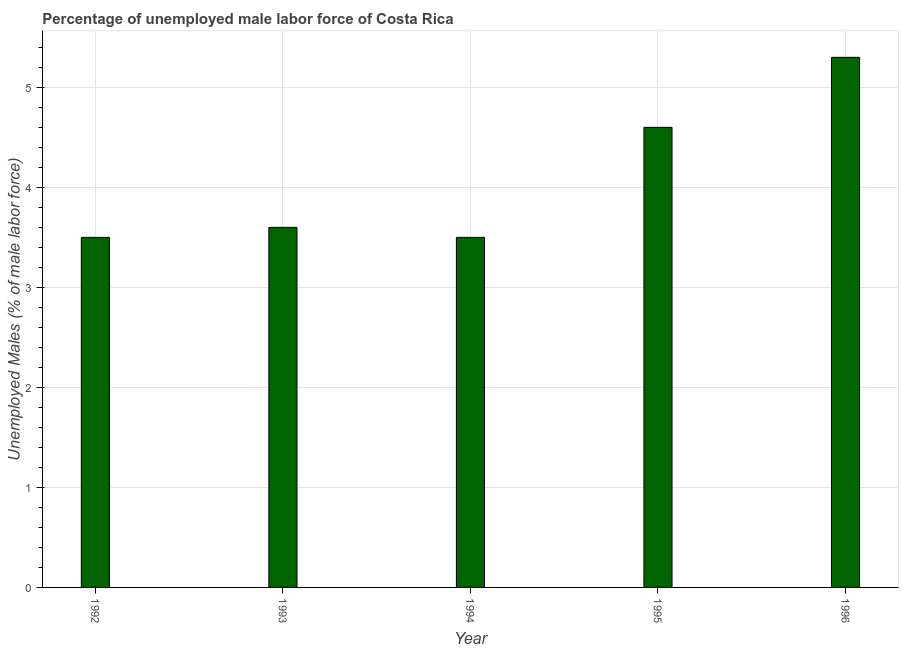Does the graph contain grids?
Ensure brevity in your answer.  Yes. What is the title of the graph?
Your answer should be compact. Percentage of unemployed male labor force of Costa Rica. What is the label or title of the X-axis?
Ensure brevity in your answer.  Year. What is the label or title of the Y-axis?
Make the answer very short. Unemployed Males (% of male labor force). What is the total unemployed male labour force in 1996?
Provide a succinct answer. 5.3. Across all years, what is the maximum total unemployed male labour force?
Make the answer very short. 5.3. Across all years, what is the minimum total unemployed male labour force?
Your answer should be compact. 3.5. In which year was the total unemployed male labour force maximum?
Your response must be concise. 1996. In which year was the total unemployed male labour force minimum?
Offer a terse response. 1992. What is the sum of the total unemployed male labour force?
Provide a succinct answer. 20.5. What is the median total unemployed male labour force?
Give a very brief answer. 3.6. In how many years, is the total unemployed male labour force greater than 0.6 %?
Offer a very short reply. 5. Do a majority of the years between 1992 and 1996 (inclusive) have total unemployed male labour force greater than 3.2 %?
Make the answer very short. Yes. Is the difference between the total unemployed male labour force in 1994 and 1995 greater than the difference between any two years?
Offer a very short reply. No. Is the sum of the total unemployed male labour force in 1992 and 1995 greater than the maximum total unemployed male labour force across all years?
Your answer should be compact. Yes. What is the difference between the highest and the lowest total unemployed male labour force?
Offer a terse response. 1.8. How many bars are there?
Your answer should be compact. 5. What is the Unemployed Males (% of male labor force) in 1993?
Provide a succinct answer. 3.6. What is the Unemployed Males (% of male labor force) in 1994?
Your answer should be compact. 3.5. What is the Unemployed Males (% of male labor force) of 1995?
Your answer should be compact. 4.6. What is the Unemployed Males (% of male labor force) of 1996?
Your answer should be compact. 5.3. What is the difference between the Unemployed Males (% of male labor force) in 1992 and 1995?
Offer a very short reply. -1.1. What is the ratio of the Unemployed Males (% of male labor force) in 1992 to that in 1993?
Provide a short and direct response. 0.97. What is the ratio of the Unemployed Males (% of male labor force) in 1992 to that in 1994?
Ensure brevity in your answer.  1. What is the ratio of the Unemployed Males (% of male labor force) in 1992 to that in 1995?
Offer a terse response. 0.76. What is the ratio of the Unemployed Males (% of male labor force) in 1992 to that in 1996?
Offer a very short reply. 0.66. What is the ratio of the Unemployed Males (% of male labor force) in 1993 to that in 1994?
Provide a succinct answer. 1.03. What is the ratio of the Unemployed Males (% of male labor force) in 1993 to that in 1995?
Your response must be concise. 0.78. What is the ratio of the Unemployed Males (% of male labor force) in 1993 to that in 1996?
Make the answer very short. 0.68. What is the ratio of the Unemployed Males (% of male labor force) in 1994 to that in 1995?
Provide a short and direct response. 0.76. What is the ratio of the Unemployed Males (% of male labor force) in 1994 to that in 1996?
Ensure brevity in your answer.  0.66. What is the ratio of the Unemployed Males (% of male labor force) in 1995 to that in 1996?
Offer a terse response. 0.87. 